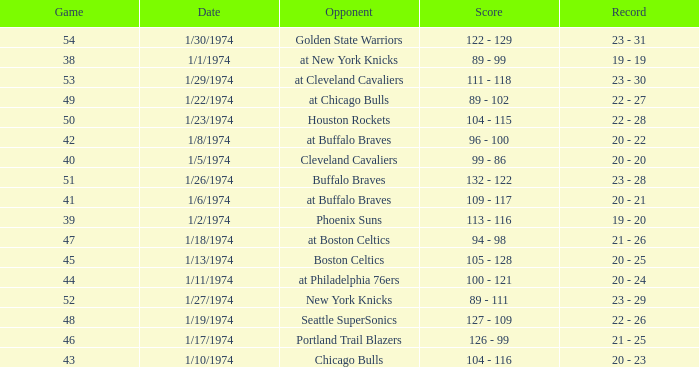What was the record after game 51 on 1/27/1974? 23 - 29. 